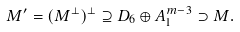<formula> <loc_0><loc_0><loc_500><loc_500>M ^ { \prime } = ( M ^ { \perp } ) ^ { \perp } \supseteq D _ { 6 } \oplus A _ { 1 } ^ { m - 3 } \supset M .</formula> 